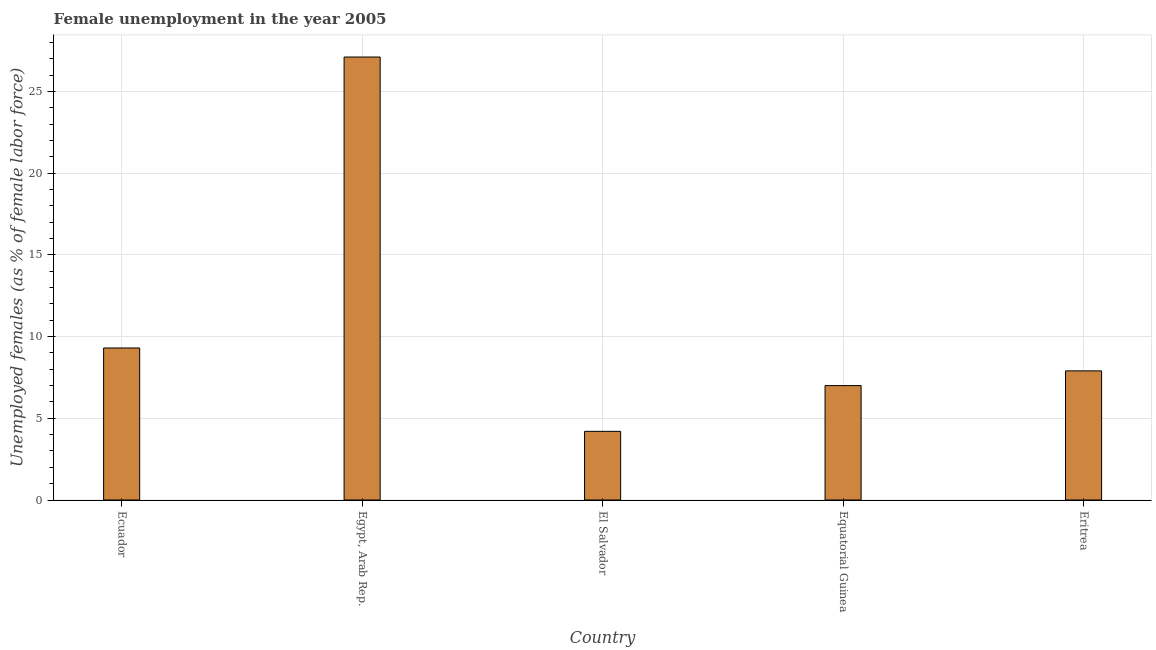What is the title of the graph?
Offer a very short reply. Female unemployment in the year 2005. What is the label or title of the Y-axis?
Your answer should be compact. Unemployed females (as % of female labor force). What is the unemployed females population in Ecuador?
Make the answer very short. 9.3. Across all countries, what is the maximum unemployed females population?
Your response must be concise. 27.1. Across all countries, what is the minimum unemployed females population?
Your answer should be very brief. 4.2. In which country was the unemployed females population maximum?
Offer a terse response. Egypt, Arab Rep. In which country was the unemployed females population minimum?
Provide a short and direct response. El Salvador. What is the sum of the unemployed females population?
Provide a short and direct response. 55.5. What is the difference between the unemployed females population in Egypt, Arab Rep. and El Salvador?
Make the answer very short. 22.9. What is the median unemployed females population?
Ensure brevity in your answer.  7.9. What is the ratio of the unemployed females population in Equatorial Guinea to that in Eritrea?
Offer a very short reply. 0.89. Is the difference between the unemployed females population in El Salvador and Equatorial Guinea greater than the difference between any two countries?
Your answer should be very brief. No. What is the difference between the highest and the second highest unemployed females population?
Offer a terse response. 17.8. Is the sum of the unemployed females population in Ecuador and Eritrea greater than the maximum unemployed females population across all countries?
Provide a short and direct response. No. What is the difference between the highest and the lowest unemployed females population?
Give a very brief answer. 22.9. How many bars are there?
Offer a very short reply. 5. Are all the bars in the graph horizontal?
Your answer should be compact. No. How many countries are there in the graph?
Offer a terse response. 5. What is the difference between two consecutive major ticks on the Y-axis?
Your answer should be compact. 5. Are the values on the major ticks of Y-axis written in scientific E-notation?
Your answer should be very brief. No. What is the Unemployed females (as % of female labor force) in Ecuador?
Your response must be concise. 9.3. What is the Unemployed females (as % of female labor force) in Egypt, Arab Rep.?
Your response must be concise. 27.1. What is the Unemployed females (as % of female labor force) of El Salvador?
Give a very brief answer. 4.2. What is the Unemployed females (as % of female labor force) of Eritrea?
Ensure brevity in your answer.  7.9. What is the difference between the Unemployed females (as % of female labor force) in Ecuador and Egypt, Arab Rep.?
Ensure brevity in your answer.  -17.8. What is the difference between the Unemployed females (as % of female labor force) in Ecuador and El Salvador?
Your answer should be very brief. 5.1. What is the difference between the Unemployed females (as % of female labor force) in Ecuador and Equatorial Guinea?
Provide a short and direct response. 2.3. What is the difference between the Unemployed females (as % of female labor force) in Ecuador and Eritrea?
Make the answer very short. 1.4. What is the difference between the Unemployed females (as % of female labor force) in Egypt, Arab Rep. and El Salvador?
Provide a succinct answer. 22.9. What is the difference between the Unemployed females (as % of female labor force) in Egypt, Arab Rep. and Equatorial Guinea?
Make the answer very short. 20.1. What is the difference between the Unemployed females (as % of female labor force) in Egypt, Arab Rep. and Eritrea?
Provide a succinct answer. 19.2. What is the difference between the Unemployed females (as % of female labor force) in El Salvador and Equatorial Guinea?
Give a very brief answer. -2.8. What is the difference between the Unemployed females (as % of female labor force) in Equatorial Guinea and Eritrea?
Your answer should be compact. -0.9. What is the ratio of the Unemployed females (as % of female labor force) in Ecuador to that in Egypt, Arab Rep.?
Provide a short and direct response. 0.34. What is the ratio of the Unemployed females (as % of female labor force) in Ecuador to that in El Salvador?
Ensure brevity in your answer.  2.21. What is the ratio of the Unemployed females (as % of female labor force) in Ecuador to that in Equatorial Guinea?
Give a very brief answer. 1.33. What is the ratio of the Unemployed females (as % of female labor force) in Ecuador to that in Eritrea?
Provide a short and direct response. 1.18. What is the ratio of the Unemployed females (as % of female labor force) in Egypt, Arab Rep. to that in El Salvador?
Your answer should be compact. 6.45. What is the ratio of the Unemployed females (as % of female labor force) in Egypt, Arab Rep. to that in Equatorial Guinea?
Your answer should be compact. 3.87. What is the ratio of the Unemployed females (as % of female labor force) in Egypt, Arab Rep. to that in Eritrea?
Offer a terse response. 3.43. What is the ratio of the Unemployed females (as % of female labor force) in El Salvador to that in Eritrea?
Ensure brevity in your answer.  0.53. What is the ratio of the Unemployed females (as % of female labor force) in Equatorial Guinea to that in Eritrea?
Offer a very short reply. 0.89. 